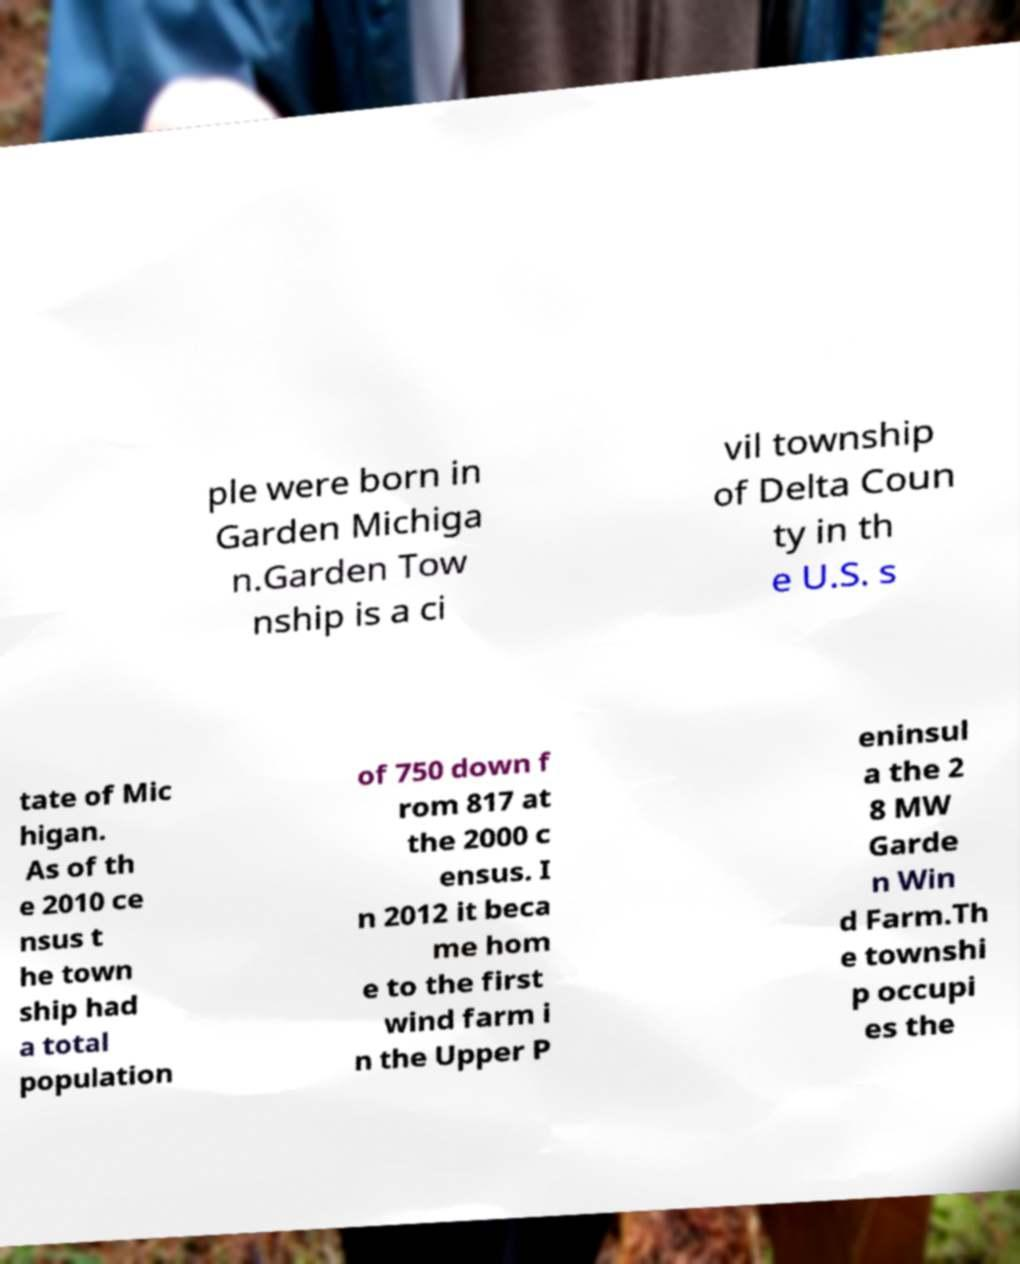What messages or text are displayed in this image? I need them in a readable, typed format. ple were born in Garden Michiga n.Garden Tow nship is a ci vil township of Delta Coun ty in th e U.S. s tate of Mic higan. As of th e 2010 ce nsus t he town ship had a total population of 750 down f rom 817 at the 2000 c ensus. I n 2012 it beca me hom e to the first wind farm i n the Upper P eninsul a the 2 8 MW Garde n Win d Farm.Th e townshi p occupi es the 